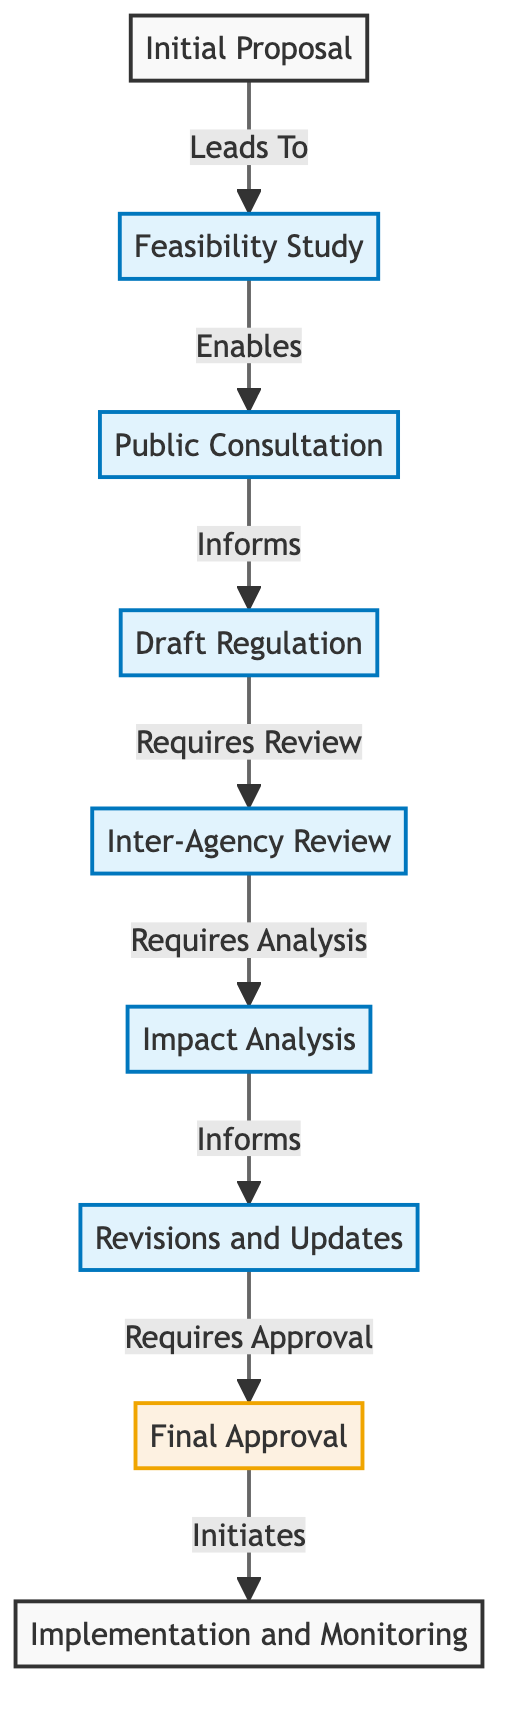What is the starting point of the regulatory process? The diagram indicates that the starting point is "Initial Proposal," which is the first node where the process begins.
Answer: Initial Proposal How many nodes are there in the diagram? By counting all the distinct points in the diagram, there are nine nodes representing various stages of the regulatory process.
Answer: 9 What relationship describes the connection between "Impact Analysis" and "Revisions and Updates"? From the diagram, the connection is labeled as "Informs," indicating that the information gathered during Impact Analysis contributes to the revisions made in Updates.
Answer: Informs What comes directly after "Public Consultation"? According to the directed graph, "Public Consultation" leads directly to "Draft Regulation," as indicated by the relationship flow.
Answer: Draft Regulation Which stage requires formal approval before proceeding? The diagram shows that "Final Approval" is the stage that necessitates formal approval from regulatory bodies before advancing to the implementation phase.
Answer: Final Approval Is "Feasibility Study" directly followed by anything? Yes, the diagram denotes that the "Feasibility Study" directly enables the "Public Consultation," creating a sequential flow from one to the other.
Answer: Public Consultation What is the last stage of the regulatory process? The diagram concludes with the node "Implementation and Monitoring," serving as the final step after all previous processes have been completed.
Answer: Implementation and Monitoring What type of analysis is required after the "Inter-Agency Review"? The directed graph specifies that an "Impact Analysis" is required following the review conducted by relevant agencies.
Answer: Impact Analysis How does the process initiate after approval? After receiving "Final Approval," the process is initiated into the final phase, which involves "Implementation and Monitoring," as indicated by the flow from one node to the next.
Answer: Initiates 